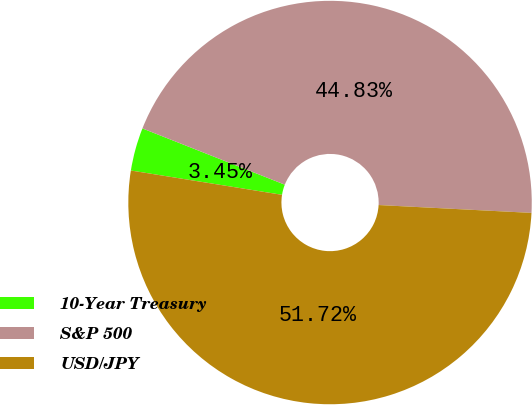Convert chart. <chart><loc_0><loc_0><loc_500><loc_500><pie_chart><fcel>10-Year Treasury<fcel>S&P 500<fcel>USD/JPY<nl><fcel>3.45%<fcel>44.83%<fcel>51.72%<nl></chart> 